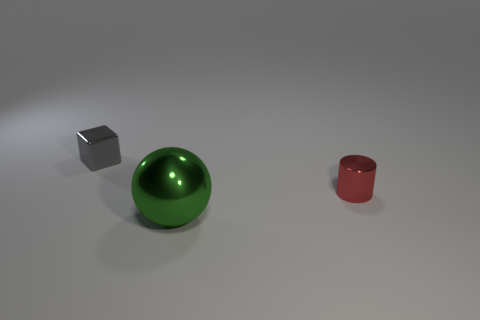Are there fewer shiny cubes that are on the right side of the large object than metallic objects that are to the left of the tiny cylinder?
Your response must be concise. Yes. What color is the thing that is behind the green ball and left of the shiny cylinder?
Offer a terse response. Gray. There is a shiny ball; is it the same size as the thing behind the cylinder?
Keep it short and to the point. No. There is a small object that is behind the cylinder; what shape is it?
Your response must be concise. Cube. Are there more green things that are in front of the gray cube than yellow cylinders?
Ensure brevity in your answer.  Yes. There is a tiny thing in front of the tiny metal object behind the tiny red metallic object; how many small gray metal blocks are to the right of it?
Make the answer very short. 0. Does the object behind the tiny red shiny thing have the same size as the metallic thing that is right of the green thing?
Make the answer very short. Yes. What number of objects are either things that are on the left side of the big green sphere or large objects?
Your answer should be very brief. 2. Is the number of red cylinders to the right of the green shiny ball the same as the number of large green spheres on the right side of the red thing?
Offer a terse response. No. What is the object behind the small metallic thing in front of the object on the left side of the big green metallic thing made of?
Provide a succinct answer. Metal. 